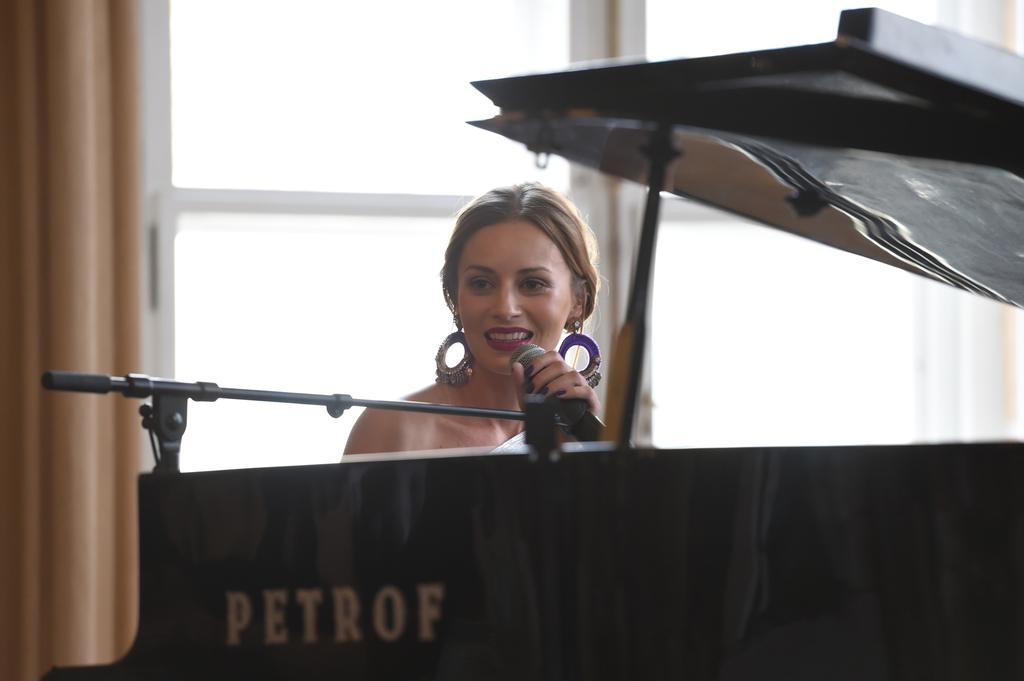What is the main feature of the image? There is a stage in the image. What is the woman on the stage doing? The woman is holding a microphone. What is the woman's focus in the image? The woman is looking at something. What type of accessory is the woman wearing? The woman is wearing earrings. What can be seen behind the woman on the stage? There is a big window behind the woman. What type of flooring is present in the image? There is a mat in the image. What is the position of the men in the image? There are no men present in the image. 